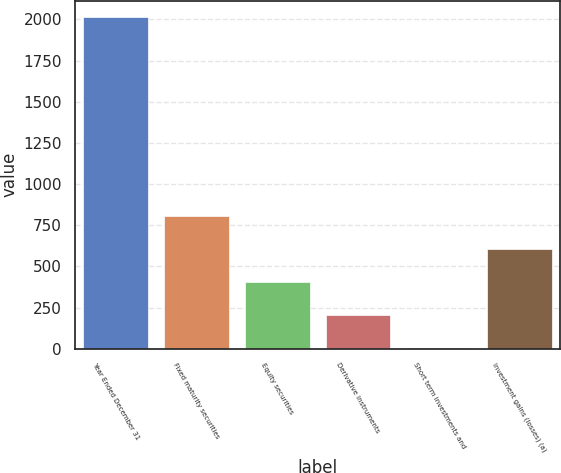<chart> <loc_0><loc_0><loc_500><loc_500><bar_chart><fcel>Year Ended December 31<fcel>Fixed maturity securities<fcel>Equity securities<fcel>Derivative instruments<fcel>Short term investments and<fcel>Investment gains (losses) (a)<nl><fcel>2013<fcel>807<fcel>405<fcel>204<fcel>3<fcel>606<nl></chart> 